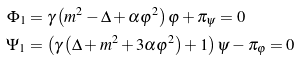Convert formula to latex. <formula><loc_0><loc_0><loc_500><loc_500>\Phi _ { 1 } & = \gamma \left ( m ^ { 2 } - \Delta + \alpha \varphi ^ { 2 } \right ) \varphi + \pi _ { \psi } = 0 \\ \Psi _ { 1 } & = \left ( \gamma \left ( \Delta + m ^ { 2 } + 3 \alpha \varphi ^ { 2 } \right ) + 1 \right ) \psi - \pi _ { \varphi } = 0</formula> 